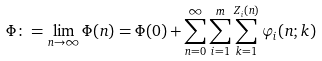<formula> <loc_0><loc_0><loc_500><loc_500>\Phi \colon = \lim _ { n \rightarrow \infty } \Phi ( n ) = \Phi ( 0 ) + \sum _ { n = 0 } ^ { \infty } \sum _ { i = 1 } ^ { m } \sum _ { k = 1 } ^ { Z _ { i } ( n ) } \varphi _ { i } ( n ; k )</formula> 